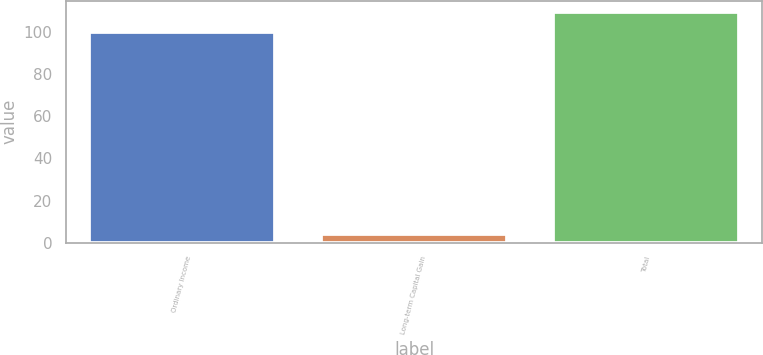<chart> <loc_0><loc_0><loc_500><loc_500><bar_chart><fcel>Ordinary Income<fcel>Long-term Capital Gain<fcel>Total<nl><fcel>100<fcel>4.09<fcel>109.59<nl></chart> 